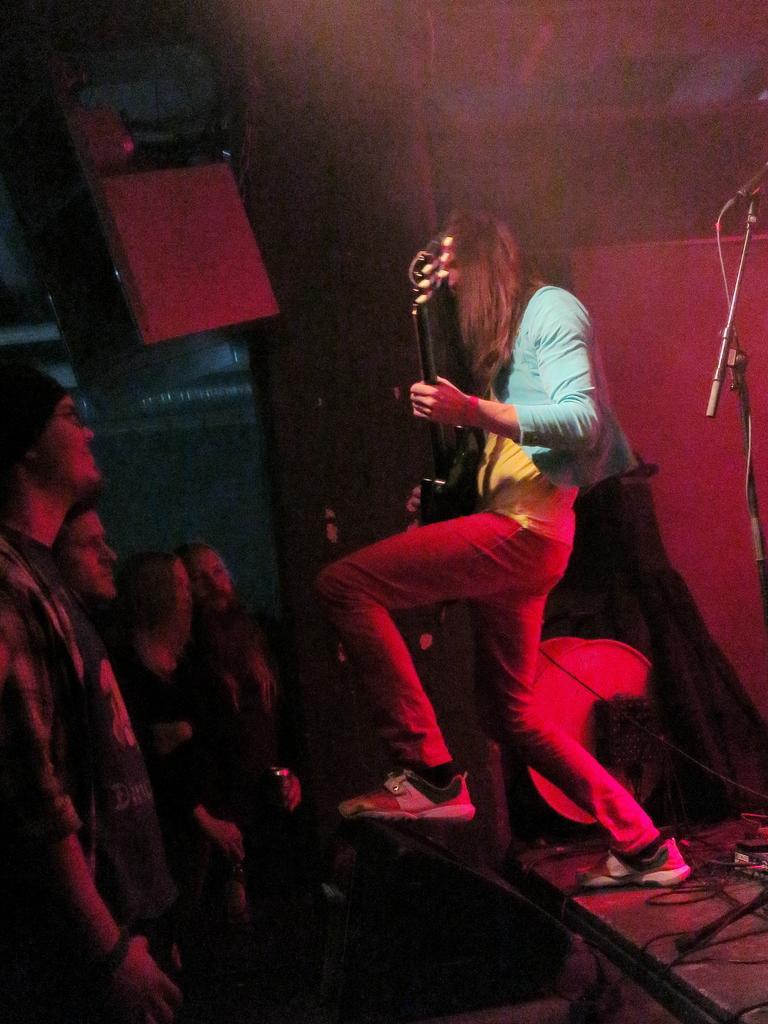Could you give a brief overview of what you see in this image? In the image there is a person playing guitar on the stage and in front there are audience looking at him. 